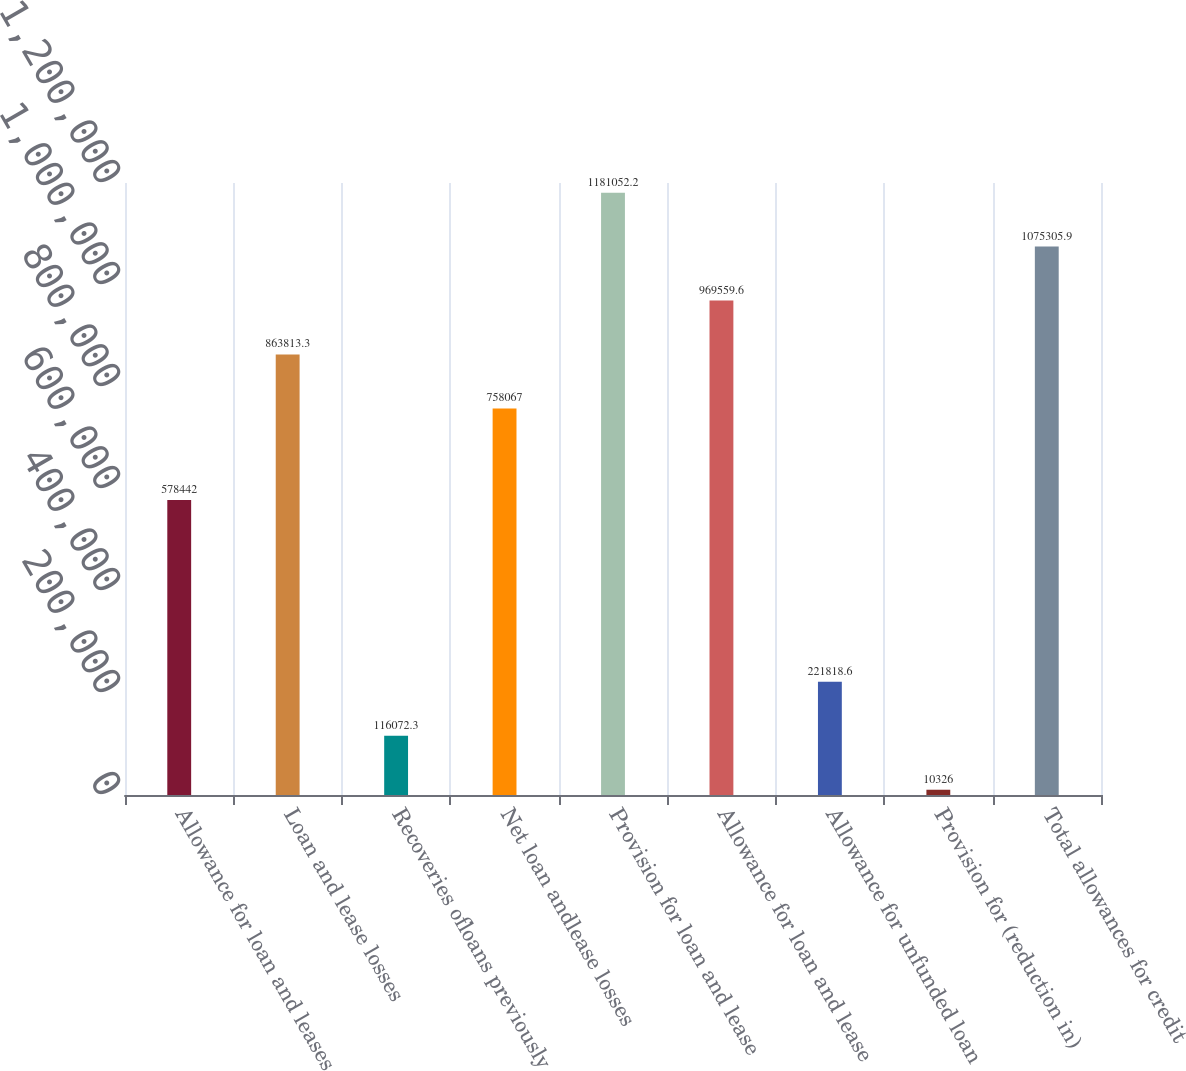Convert chart to OTSL. <chart><loc_0><loc_0><loc_500><loc_500><bar_chart><fcel>Allowance for loan and leases<fcel>Loan and lease losses<fcel>Recoveries ofloans previously<fcel>Net loan andlease losses<fcel>Provision for loan and lease<fcel>Allowance for loan and lease<fcel>Allowance for unfunded loan<fcel>Provision for (reduction in)<fcel>Total allowances for credit<nl><fcel>578442<fcel>863813<fcel>116072<fcel>758067<fcel>1.18105e+06<fcel>969560<fcel>221819<fcel>10326<fcel>1.07531e+06<nl></chart> 